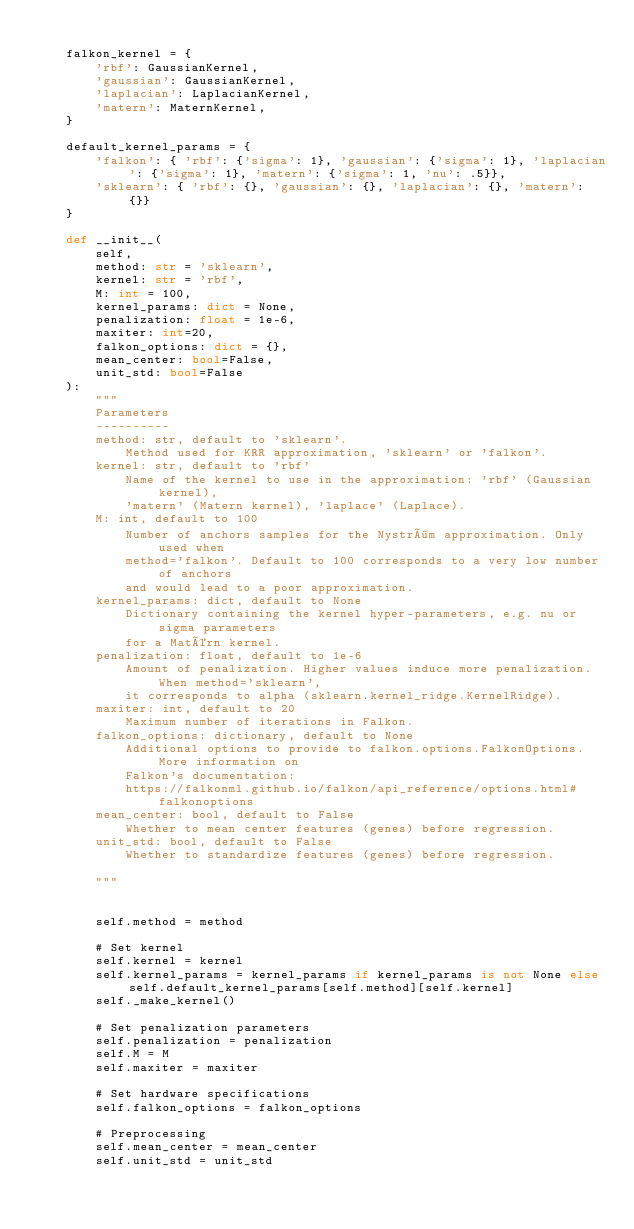<code> <loc_0><loc_0><loc_500><loc_500><_Python_>
    falkon_kernel = {
        'rbf': GaussianKernel,
        'gaussian': GaussianKernel,
        'laplacian': LaplacianKernel,
        'matern': MaternKernel,
    }

    default_kernel_params = {
        'falkon': { 'rbf': {'sigma': 1}, 'gaussian': {'sigma': 1}, 'laplacian': {'sigma': 1}, 'matern': {'sigma': 1, 'nu': .5}},
        'sklearn': { 'rbf': {}, 'gaussian': {}, 'laplacian': {}, 'matern': {}}
    }

    def __init__(
        self,
        method: str = 'sklearn',
        kernel: str = 'rbf',
        M: int = 100,
        kernel_params: dict = None,
        penalization: float = 1e-6,
        maxiter: int=20,
        falkon_options: dict = {},
        mean_center: bool=False,
        unit_std: bool=False
    ):
        """
        Parameters
        ----------
        method: str, default to 'sklearn'.
            Method used for KRR approximation, 'sklearn' or 'falkon'.
        kernel: str, default to 'rbf'
            Name of the kernel to use in the approximation: 'rbf' (Gaussian kernel), 
            'matern' (Matern kernel), 'laplace' (Laplace).
        M: int, default to 100
            Number of anchors samples for the Nyström approximation. Only used when
            method='falkon'. Default to 100 corresponds to a very low number of anchors
            and would lead to a poor approximation.
        kernel_params: dict, default to None
            Dictionary containing the kernel hyper-parameters, e.g. nu or sigma parameters
            for a Matérn kernel.
        penalization: float, default to 1e-6
            Amount of penalization. Higher values induce more penalization. When method='sklearn', 
            it corresponds to alpha (sklearn.kernel_ridge.KernelRidge).
        maxiter: int, default to 20
            Maximum number of iterations in Falkon.
        falkon_options: dictionary, default to None
            Additional options to provide to falkon.options.FalkonOptions. More information on 
            Falkon's documentation: 
            https://falkonml.github.io/falkon/api_reference/options.html#falkonoptions
        mean_center: bool, default to False
            Whether to mean center features (genes) before regression.
        unit_std: bool, default to False
            Whether to standardize features (genes) before regression.

        """


        self.method = method

        # Set kernel
        self.kernel = kernel
        self.kernel_params = kernel_params if kernel_params is not None else self.default_kernel_params[self.method][self.kernel]
        self._make_kernel()

        # Set penalization parameters
        self.penalization = penalization
        self.M = M
        self.maxiter = maxiter

        # Set hardware specifications
        self.falkon_options = falkon_options

        # Preprocessing
        self.mean_center = mean_center
        self.unit_std = unit_std</code> 